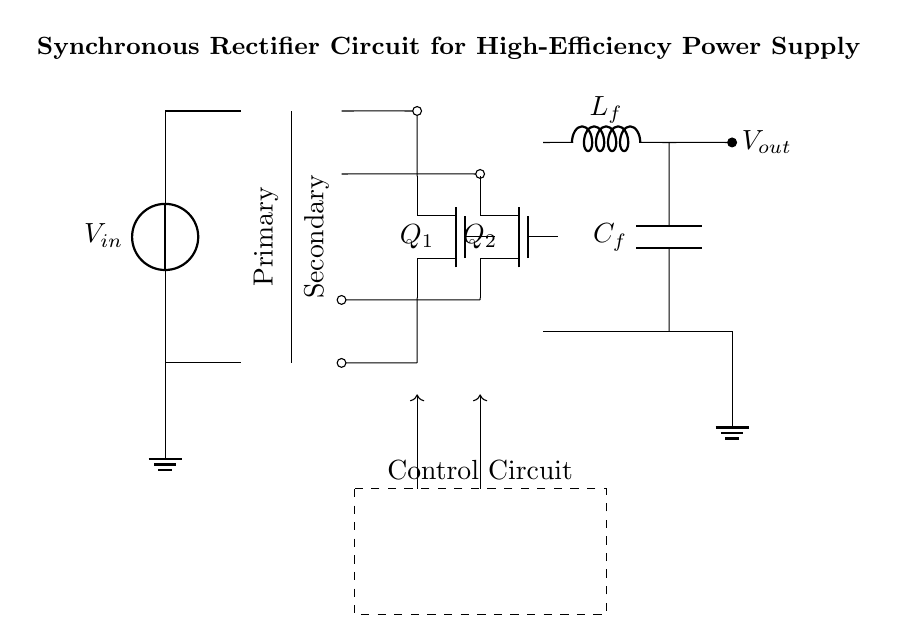What is the input voltage of the circuit? The input voltage is labeled as V_in, which is indicated at the left side of the circuit diagram.
Answer: V_in How many transistors are present in this circuit? There are two transistors, Q1 and Q2, which are marked in the circuit diagram on the secondary side.
Answer: 2 What type of inductor is used in the circuit? The inductor is labeled as L_f and is depicted on the output side of the circuit.
Answer: L_f What do the dashed lines represent in the circuit? The dashed lines form a rectangle around the components which indicate the control circuit, signifying the area dedicated to the control elements of the synchronous rectifier.
Answer: Control Circuit Which component is used for energy storage in the circuit? The capacitor labeled as C_f is used for energy storage, indicated on the output side beneath the inductor.
Answer: C_f Why are synchronous rectifiers used in this circuit? Synchronous rectifiers are utilized for their high efficiency in power supply applications, as they minimize power losses through controlled switching, improving overall performance in converting AC to DC.
Answer: High efficiency What is the primary function of the transformer in this circuit? The transformer is used to step up or step down the voltage from the primary to the secondary side, facilitating the desired voltage conversion required by the application.
Answer: Voltage conversion 